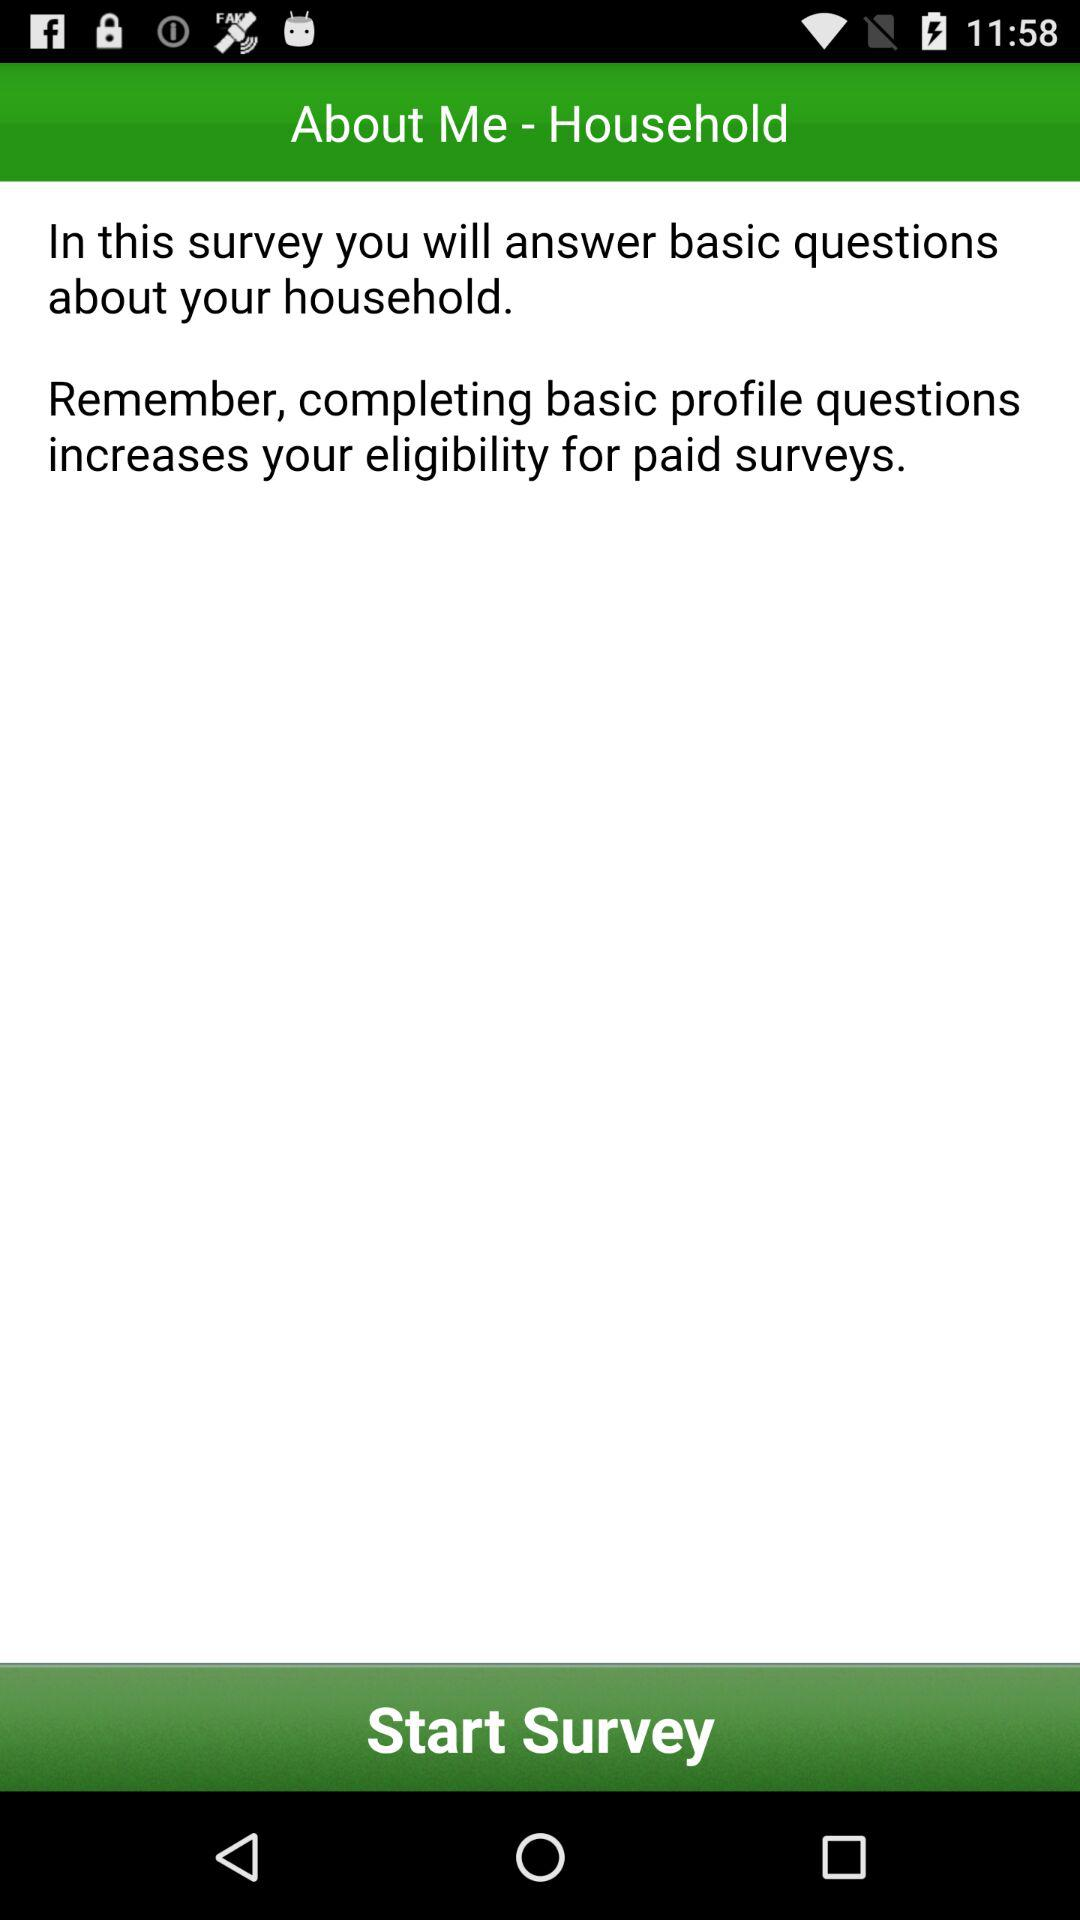What questions will we answer in this survey? You will answer basic questions in this survey. 